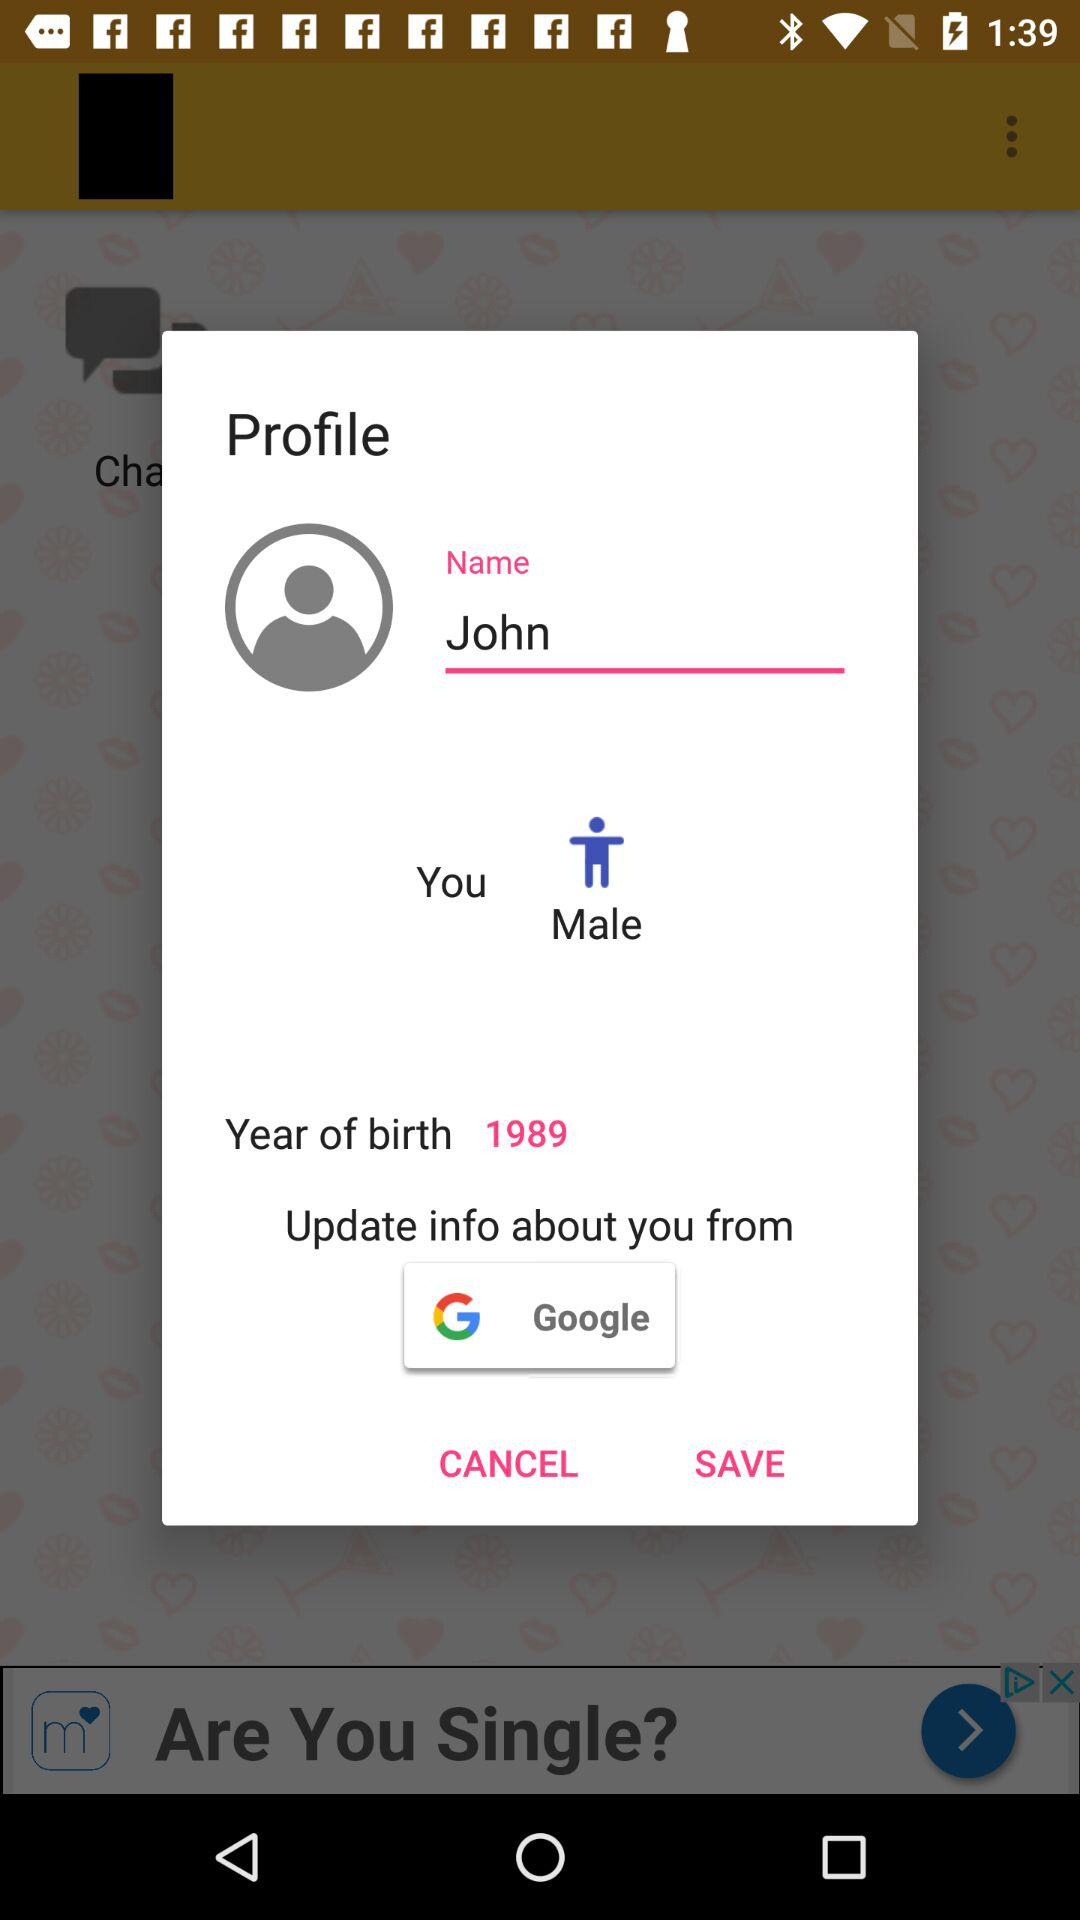What is the gender? The gender is male. 